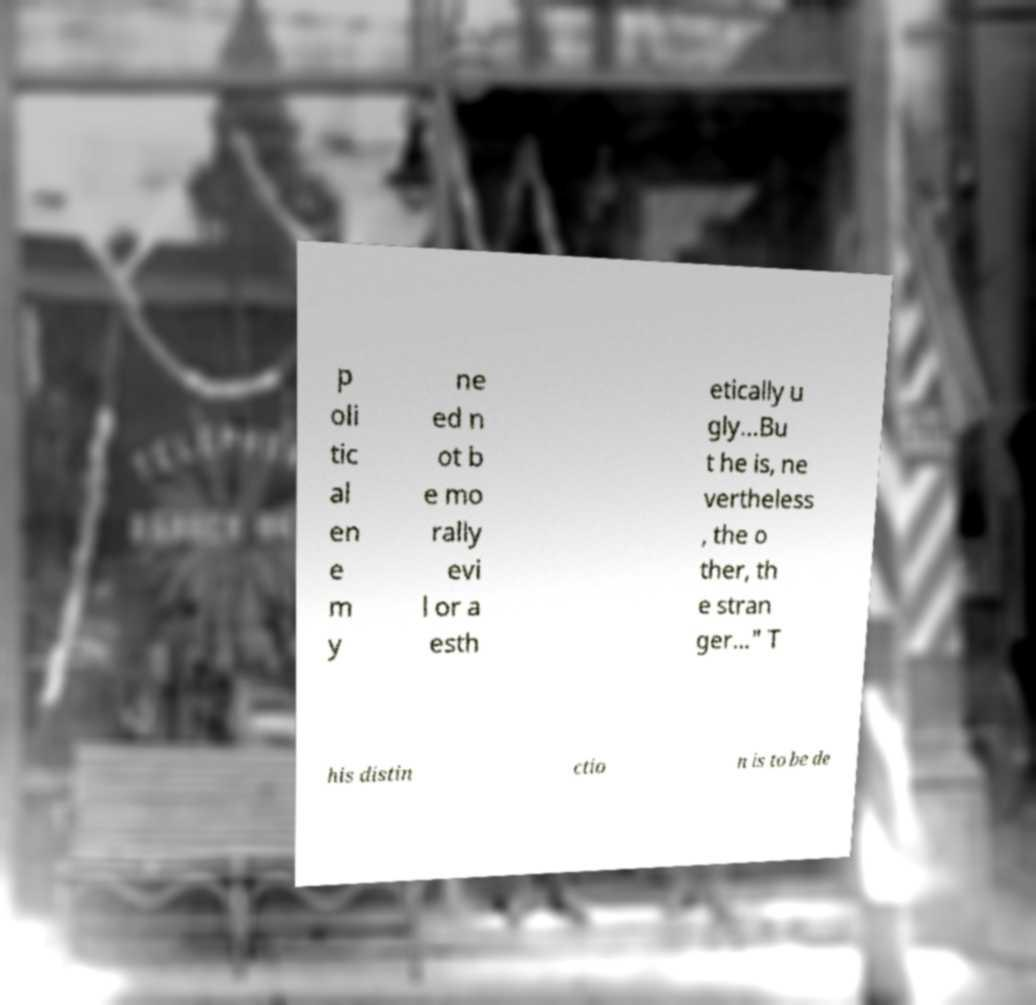What messages or text are displayed in this image? I need them in a readable, typed format. p oli tic al en e m y ne ed n ot b e mo rally evi l or a esth etically u gly...Bu t he is, ne vertheless , the o ther, th e stran ger…" T his distin ctio n is to be de 